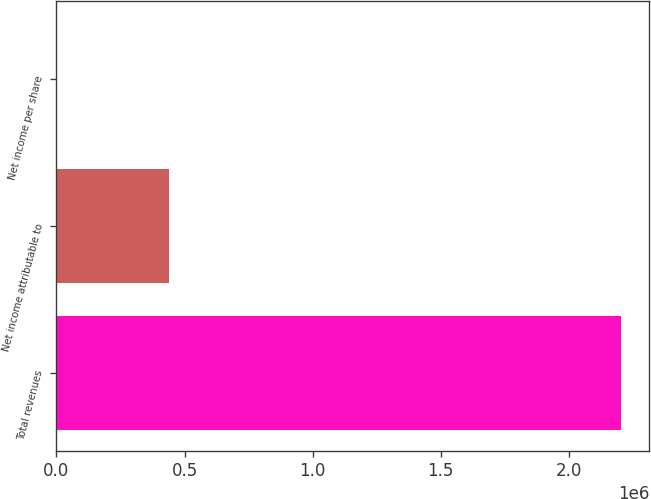Convert chart to OTSL. <chart><loc_0><loc_0><loc_500><loc_500><bar_chart><fcel>Total revenues<fcel>Net income attributable to<fcel>Net income per share<nl><fcel>2.20385e+06<fcel>440771<fcel>2.37<nl></chart> 